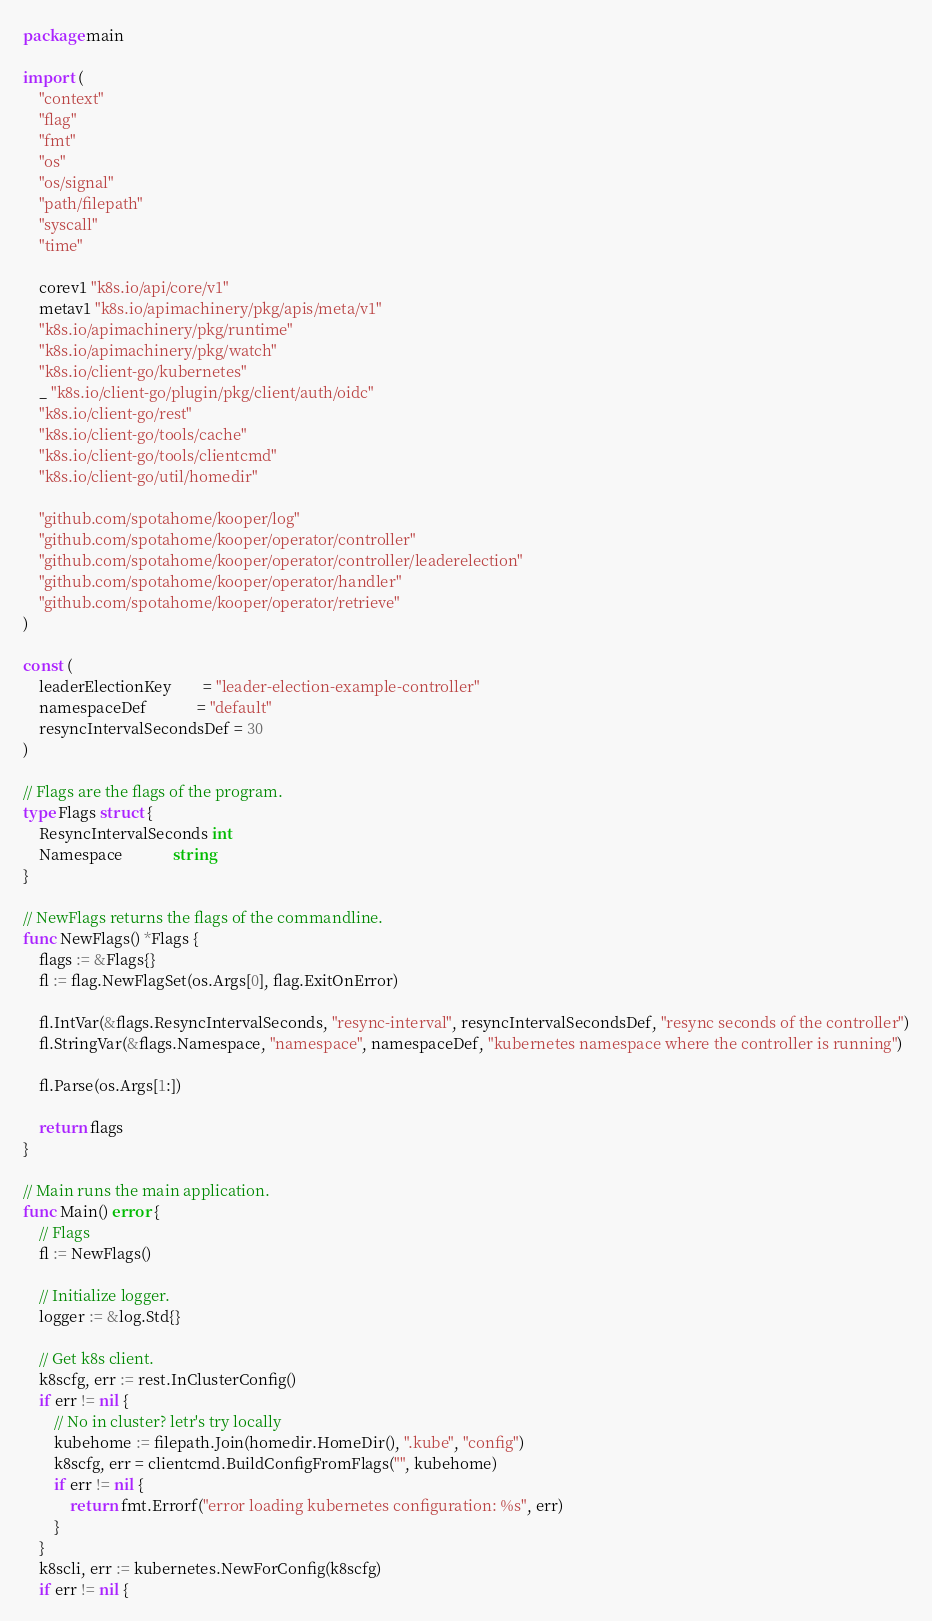<code> <loc_0><loc_0><loc_500><loc_500><_Go_>package main

import (
	"context"
	"flag"
	"fmt"
	"os"
	"os/signal"
	"path/filepath"
	"syscall"
	"time"

	corev1 "k8s.io/api/core/v1"
	metav1 "k8s.io/apimachinery/pkg/apis/meta/v1"
	"k8s.io/apimachinery/pkg/runtime"
	"k8s.io/apimachinery/pkg/watch"
	"k8s.io/client-go/kubernetes"
	_ "k8s.io/client-go/plugin/pkg/client/auth/oidc"
	"k8s.io/client-go/rest"
	"k8s.io/client-go/tools/cache"
	"k8s.io/client-go/tools/clientcmd"
	"k8s.io/client-go/util/homedir"

	"github.com/spotahome/kooper/log"
	"github.com/spotahome/kooper/operator/controller"
	"github.com/spotahome/kooper/operator/controller/leaderelection"
	"github.com/spotahome/kooper/operator/handler"
	"github.com/spotahome/kooper/operator/retrieve"
)

const (
	leaderElectionKey        = "leader-election-example-controller"
	namespaceDef             = "default"
	resyncIntervalSecondsDef = 30
)

// Flags are the flags of the program.
type Flags struct {
	ResyncIntervalSeconds int
	Namespace             string
}

// NewFlags returns the flags of the commandline.
func NewFlags() *Flags {
	flags := &Flags{}
	fl := flag.NewFlagSet(os.Args[0], flag.ExitOnError)

	fl.IntVar(&flags.ResyncIntervalSeconds, "resync-interval", resyncIntervalSecondsDef, "resync seconds of the controller")
	fl.StringVar(&flags.Namespace, "namespace", namespaceDef, "kubernetes namespace where the controller is running")

	fl.Parse(os.Args[1:])

	return flags
}

// Main runs the main application.
func Main() error {
	// Flags
	fl := NewFlags()

	// Initialize logger.
	logger := &log.Std{}

	// Get k8s client.
	k8scfg, err := rest.InClusterConfig()
	if err != nil {
		// No in cluster? letr's try locally
		kubehome := filepath.Join(homedir.HomeDir(), ".kube", "config")
		k8scfg, err = clientcmd.BuildConfigFromFlags("", kubehome)
		if err != nil {
			return fmt.Errorf("error loading kubernetes configuration: %s", err)
		}
	}
	k8scli, err := kubernetes.NewForConfig(k8scfg)
	if err != nil {</code> 